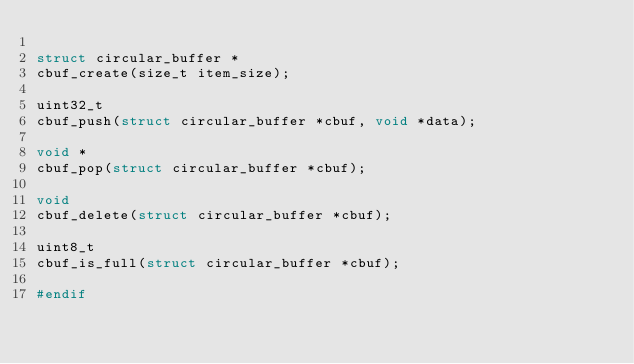<code> <loc_0><loc_0><loc_500><loc_500><_C_>
struct circular_buffer *
cbuf_create(size_t item_size);

uint32_t
cbuf_push(struct circular_buffer *cbuf, void *data);

void *
cbuf_pop(struct circular_buffer *cbuf);

void
cbuf_delete(struct circular_buffer *cbuf);

uint8_t
cbuf_is_full(struct circular_buffer *cbuf);

#endif
</code> 